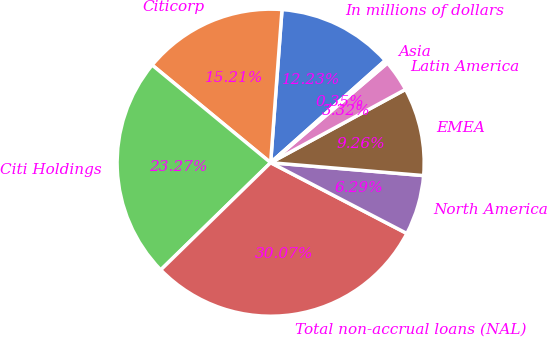Convert chart. <chart><loc_0><loc_0><loc_500><loc_500><pie_chart><fcel>In millions of dollars<fcel>Citicorp<fcel>Citi Holdings<fcel>Total non-accrual loans (NAL)<fcel>North America<fcel>EMEA<fcel>Latin America<fcel>Asia<nl><fcel>12.23%<fcel>15.21%<fcel>23.27%<fcel>30.07%<fcel>6.29%<fcel>9.26%<fcel>3.32%<fcel>0.35%<nl></chart> 